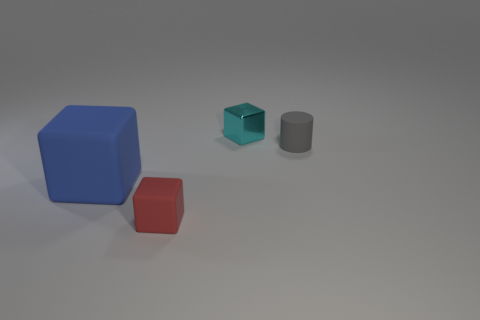What shapes and colors are the objects in the image? There are three objects: a large blue cube, a smaller teal cube, and a grey cylinder. 